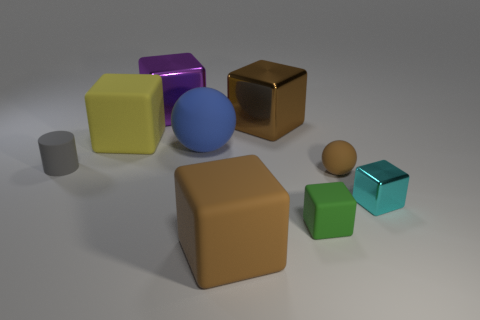Subtract 3 cubes. How many cubes are left? 3 Subtract all small rubber blocks. How many blocks are left? 5 Subtract all green blocks. How many blocks are left? 5 Subtract all gray cubes. Subtract all green cylinders. How many cubes are left? 6 Add 1 tiny gray rubber spheres. How many objects exist? 10 Subtract all cylinders. How many objects are left? 8 Subtract all big brown metal cubes. Subtract all small balls. How many objects are left? 7 Add 9 blue balls. How many blue balls are left? 10 Add 9 small purple metallic balls. How many small purple metallic balls exist? 9 Subtract 0 red spheres. How many objects are left? 9 